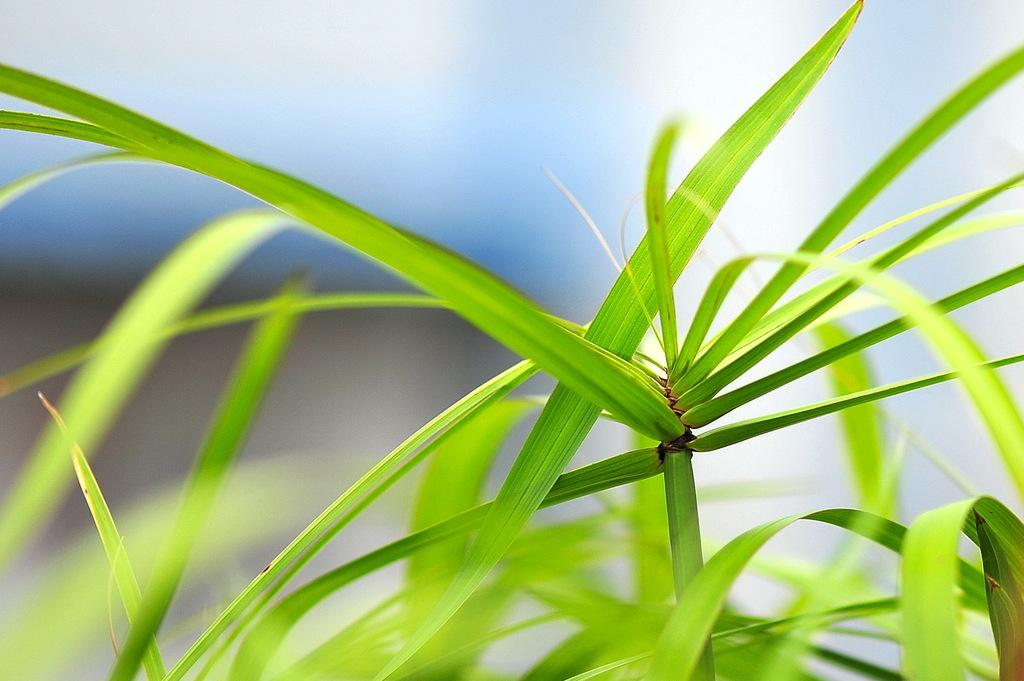What is the main subject of the image? There is a plant in the center of the image. Can you describe the background of the image? The background of the image is blurry. What type of discussion is taking place in the image? There is no discussion present in the image; it features a plant in the center and a blurry background. What statement can be made about the basin in the image? There is no basin present in the image. 